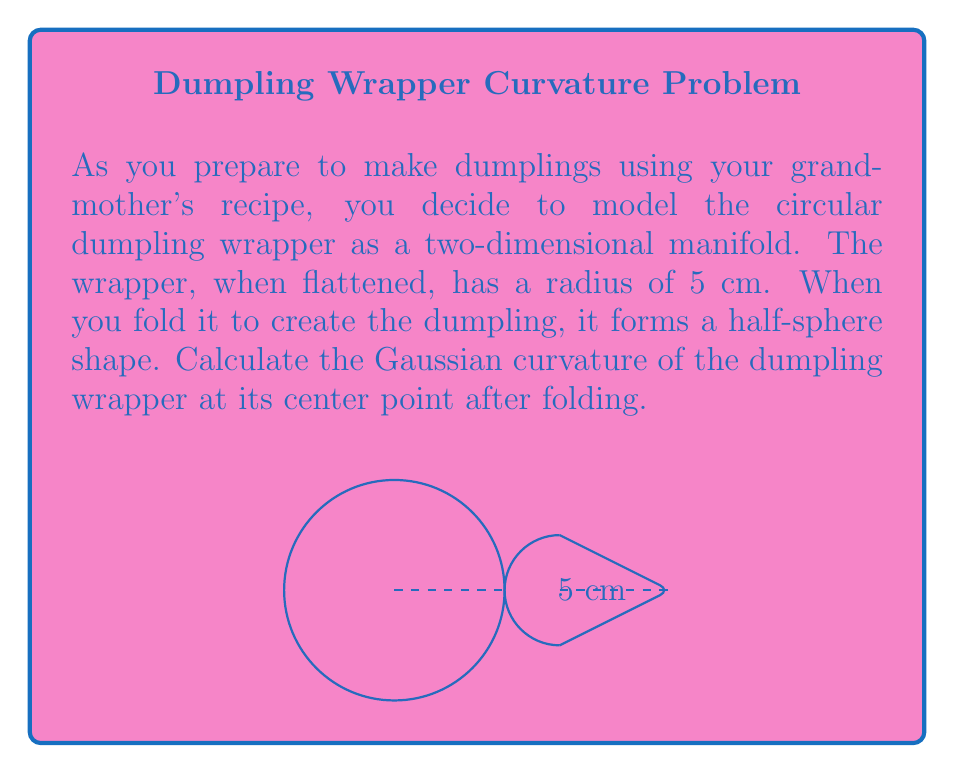Show me your answer to this math problem. Let's approach this step-by-step:

1) The dumpling wrapper starts as a flat circle and is folded into a half-sphere. The Gaussian curvature of a sphere is constant at every point on its surface.

2) For a sphere of radius $R$, the Gaussian curvature $K$ is given by:

   $$K = \frac{1}{R^2}$$

3) In this case, we need to find the radius of the sphere that our half-sphere would be part of. The flat circle has a radius of 5 cm, which becomes the radius of the base of the half-sphere.

4) In a sphere, this base radius (let's call it $r$) is related to the sphere's radius $R$ by:

   $$r = R$$

5) Therefore, the radius of our sphere (and half-sphere) is 5 cm.

6) Now we can calculate the Gaussian curvature:

   $$K = \frac{1}{R^2} = \frac{1}{5^2} = \frac{1}{25} = 0.04 \text{ cm}^{-2}$$

7) The units of Gaussian curvature are the inverse square of the length unit, so here it's $\text{cm}^{-2}$.
Answer: $0.04 \text{ cm}^{-2}$ 